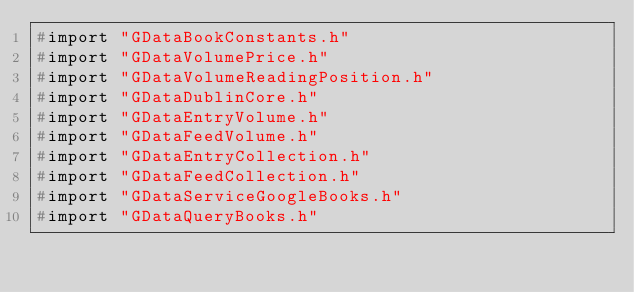Convert code to text. <code><loc_0><loc_0><loc_500><loc_500><_C_>#import "GDataBookConstants.h"
#import "GDataVolumePrice.h"
#import "GDataVolumeReadingPosition.h"
#import "GDataDublinCore.h"
#import "GDataEntryVolume.h"
#import "GDataFeedVolume.h"
#import "GDataEntryCollection.h"
#import "GDataFeedCollection.h"
#import "GDataServiceGoogleBooks.h"
#import "GDataQueryBooks.h"
</code> 